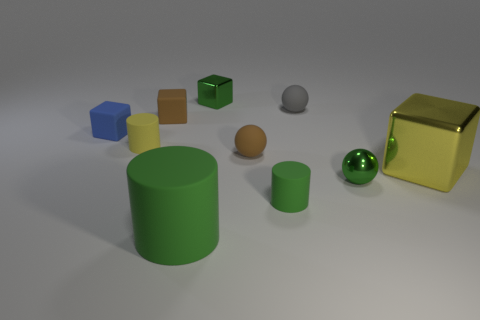Is the yellow cube made of the same material as the tiny cylinder that is in front of the small green metal ball?
Provide a succinct answer. No. The metallic ball that is the same color as the tiny shiny cube is what size?
Provide a succinct answer. Small. Are there any tiny red cylinders that have the same material as the blue thing?
Make the answer very short. No. What number of objects are either objects on the right side of the large green cylinder or tiny rubber cylinders that are left of the green block?
Offer a terse response. 7. There is a big metal thing; does it have the same shape as the small green shiny object behind the big yellow block?
Keep it short and to the point. Yes. How many other objects are the same shape as the gray thing?
Ensure brevity in your answer.  2. How many objects are either tiny cubes or gray metal things?
Your answer should be very brief. 3. Is the color of the large matte cylinder the same as the metal ball?
Your answer should be very brief. Yes. Are there any other things that have the same size as the green cube?
Give a very brief answer. Yes. There is a tiny green metallic thing that is right of the green object that is behind the yellow cylinder; what shape is it?
Give a very brief answer. Sphere. 